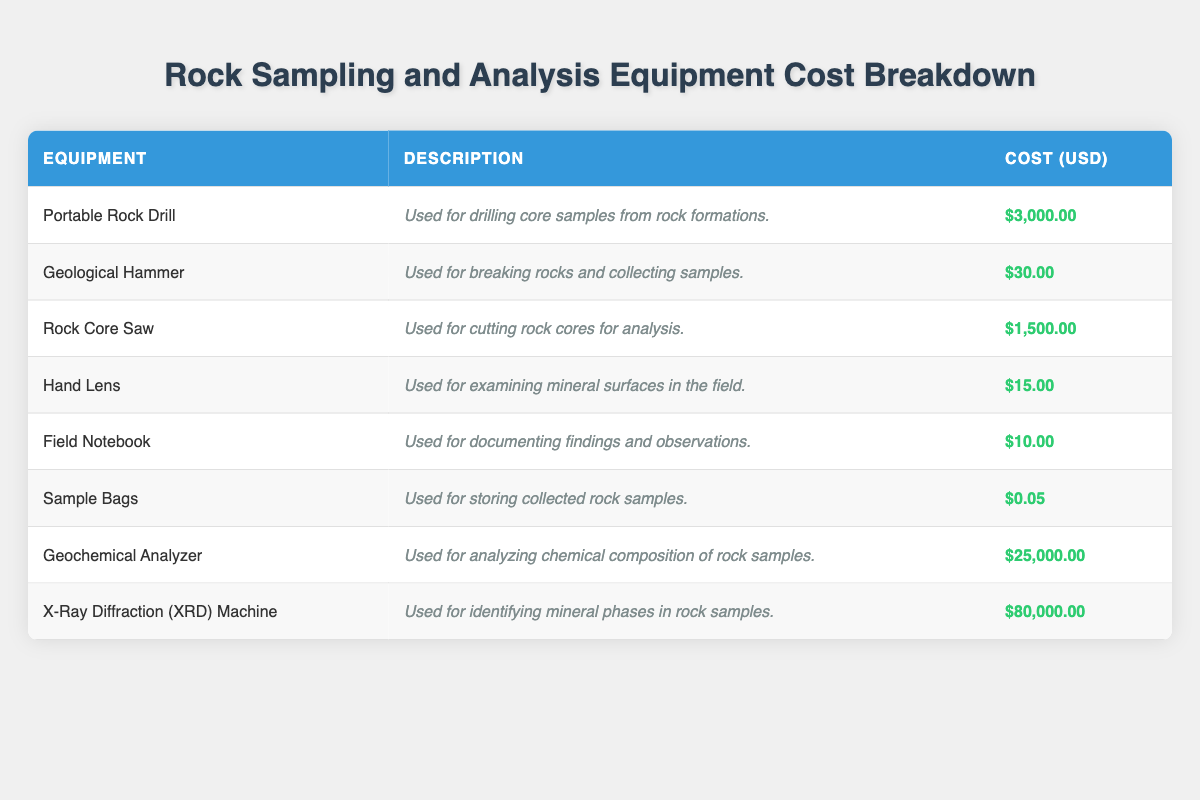What is the cost of the Portable Rock Drill? The table lists the cost of the Portable Rock Drill in the "Cost (USD)" column, which is $3,000.00.
Answer: $3,000.00 How much does a Hand Lens cost compared to a Geological Hammer? From the table, the Hand Lens costs $15.00 and the Geological Hammer costs $30.00. The Hand Lens costs half as much as the Geological Hammer.
Answer: The Hand Lens costs half as much What is the total cost of all rock sampling equipment listed? We can calculate the total cost by summing all the costs from the table: $3,000.00 + $30.00 + $1,500.00 + $15.00 + $10.00 + $0.05 + $25,000.00 + $80,000.00 = $109,555.05.
Answer: $109,555.05 Is the cost of a Geochemical Analyzer greater than both the Rock Core Saw and Geological Hammer combined? The cost of the Geochemical Analyzer is $25,000.00. The Rock Core Saw costs $1,500.00 and the Geological Hammer costs $30.00. Combined, they total $1,500.00 + $30.00 = $1,530.00. $25,000.00 is indeed greater than $1,530.00.
Answer: Yes What is the average cost of the equipment items that cost less than $100? First, we identify all items that cost less than $100 from the table: Geological Hammer ($30.00), Hand Lens ($15.00), Field Notebook ($10.00), and Sample Bags ($0.05). There are 4 items, and their total cost is $30.00 + $15.00 + $10.00 + $0.05 = $55.05. To find the average, we divide by the number of items: $55.05 / 4 = $13.7625.
Answer: $13.76 Does the X-Ray Diffraction Machine have the highest cost among all the equipment listed? The total cost of the X-Ray Diffraction Machine is $80,000.00. Comparing this with all costs in the table, $80,000.00 is higher than all other equipment costs, which confirms it has the highest cost.
Answer: Yes 